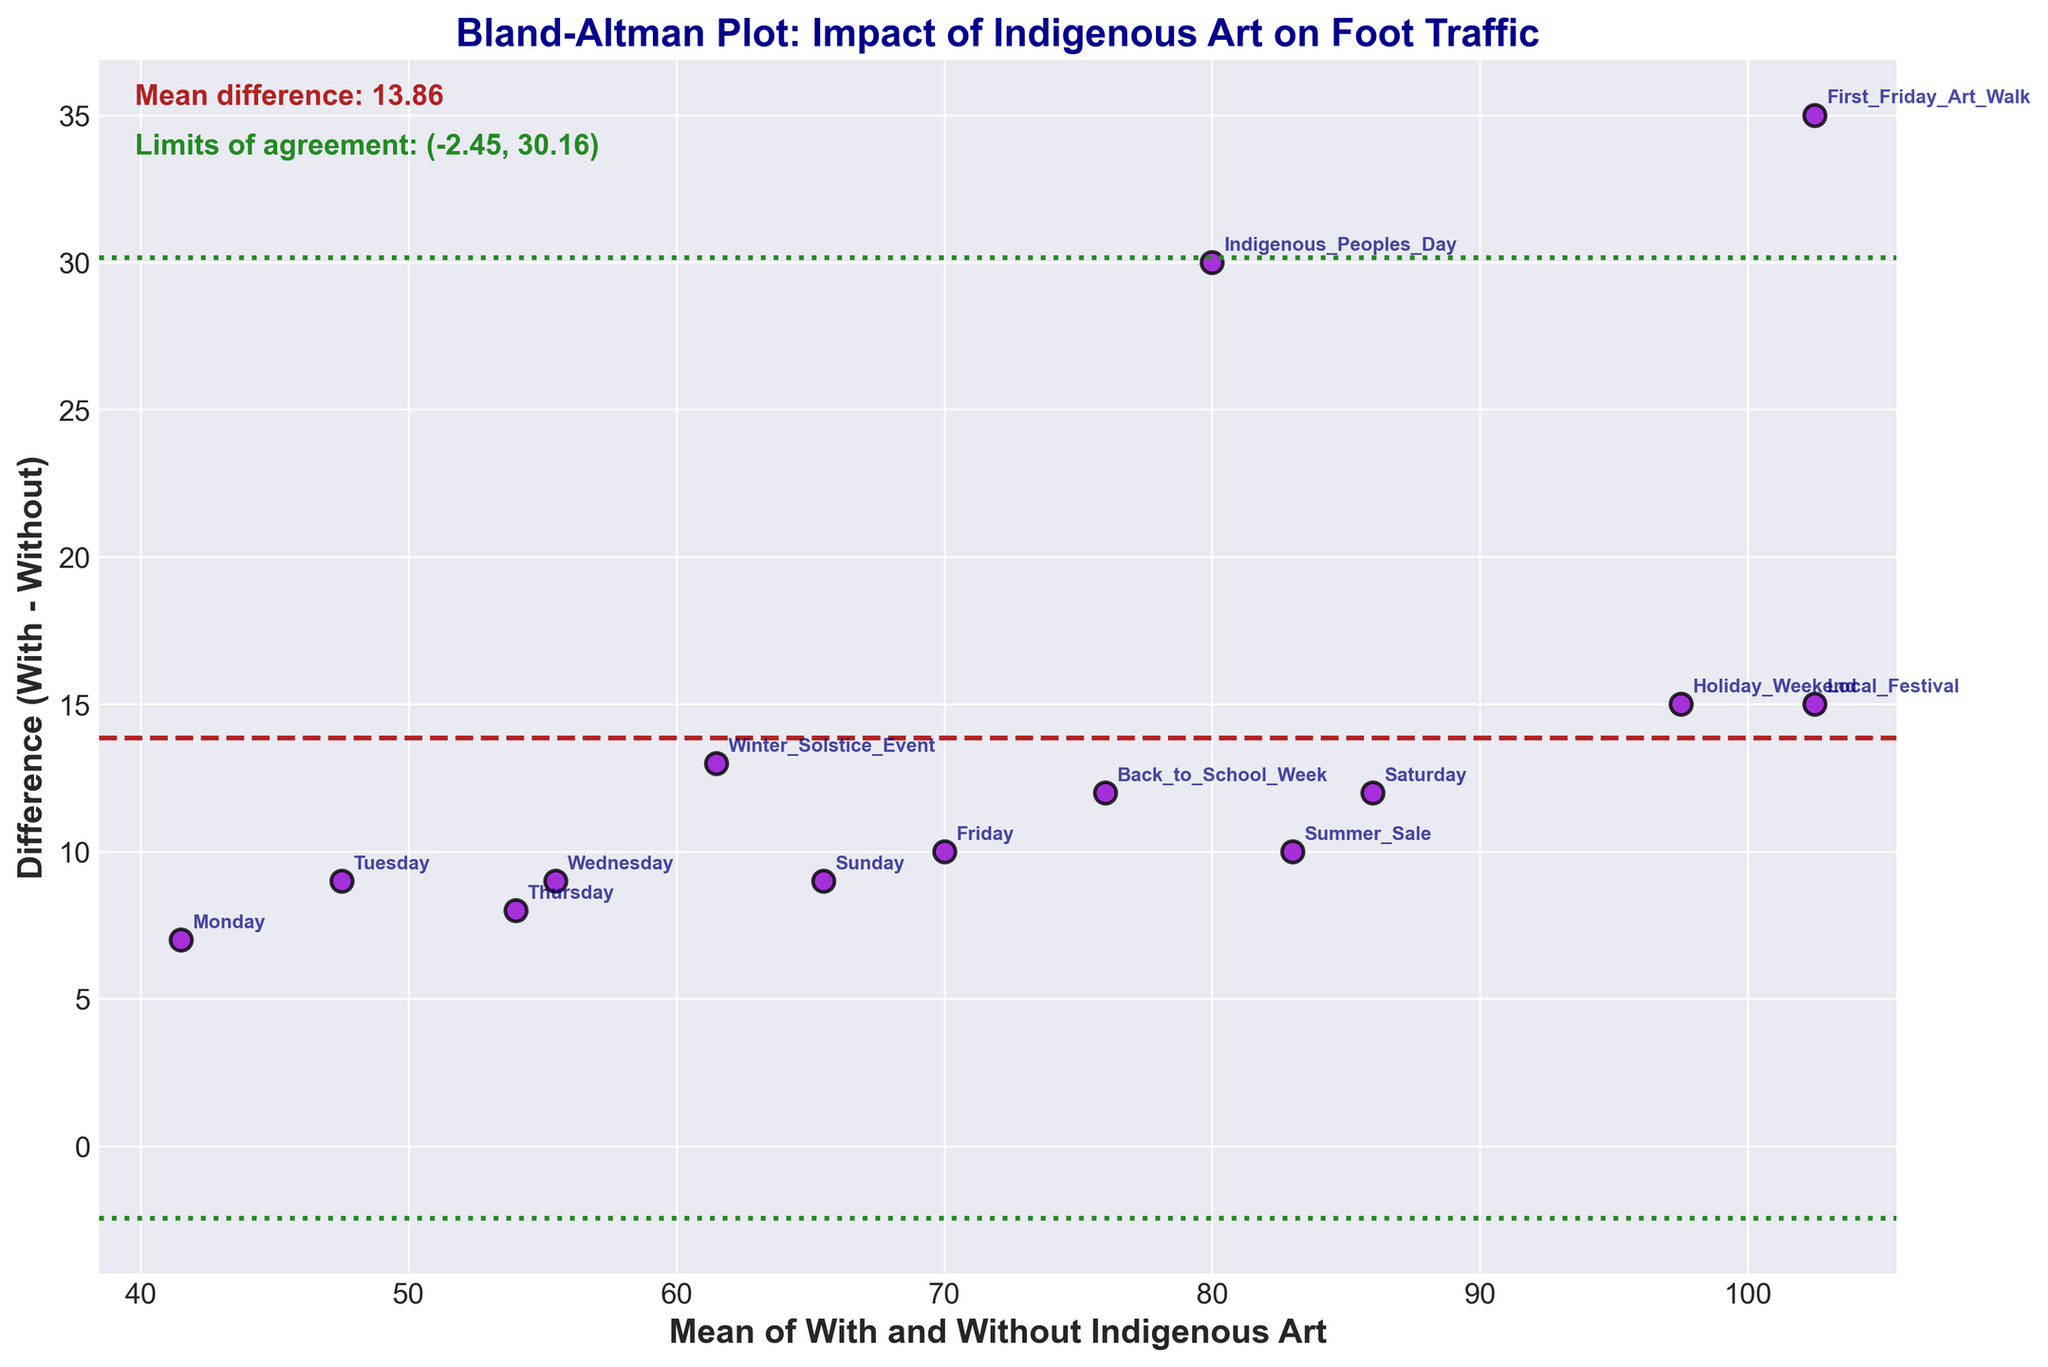How many data points are displayed in the plot? Count the number of data points (or dots) visible on the plot. Each data point corresponds to a specific day or event.
Answer: 14 What is the title of the plot? Read the text at the top of the plot to find the title.
Answer: Bland-Altman Plot: Impact of Indigenous Art on Foot Traffic What is the mean difference between days with and without indigenous art? Look for the horizontal line representing the mean difference in the plot and read the accompanying text indicating its value.
Answer: About 16.14 What are the limits of agreement? Identify the two horizontal lines (dashed or dotted) above and below the mean difference line and read the accompanying text indicating their values.
Answer: Approximately (3.99, 28.29) Which day or event had the highest difference in foot traffic between with and without indigenous art? Look for the highest point (largest positive value) on the vertical axis and note the annotated label.
Answer: First Friday Art Walk What is the average foot traffic on days with indigenous art? Sum up all the foot traffic values with indigenous art and divide by the total number of days/events. (45 + 52 + 60 + 58 + 75 + 92 + 70 + 105 + 120 + 110 + 88 + 82 + 68 + 95) / 14 = 83.71
Answer: 83.71 Which day or event had the smallest difference in foot traffic between with and without indigenous art? Look for the point closest to zero on the vertical axis and note the annotated label.
Answer: Summer Sale Which days or events had a negative difference in foot traffic? Identify any points below the zero line on the vertical axis and note their annotated labels.
Answer: None What does a point above the mean difference line indicate about foot traffic? Points above the mean difference line indicate that foot traffic was higher on that day with indigenous art displays compared to without.
Answer: Higher with art How does 'Indigenous Peoples Day' compare to 'Back to School Week' in terms of difference in foot traffic? Compare the vertical positions of the points labeled 'Indigenous Peoples Day' and 'Back to School Week'. 'Indigenous Peoples Day' has a higher difference in foot traffic (closer to the top).
Answer: Indigenous Peoples Day has a higher difference 